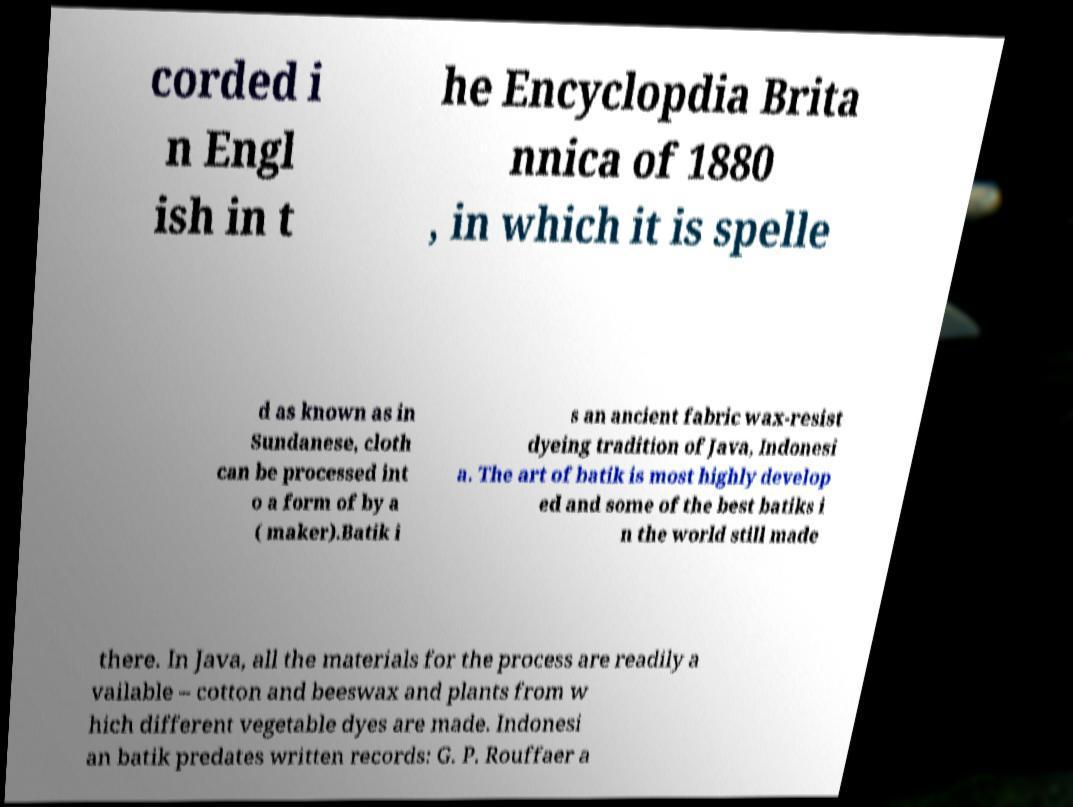Can you read and provide the text displayed in the image?This photo seems to have some interesting text. Can you extract and type it out for me? corded i n Engl ish in t he Encyclopdia Brita nnica of 1880 , in which it is spelle d as known as in Sundanese, cloth can be processed int o a form of by a ( maker).Batik i s an ancient fabric wax-resist dyeing tradition of Java, Indonesi a. The art of batik is most highly develop ed and some of the best batiks i n the world still made there. In Java, all the materials for the process are readily a vailable – cotton and beeswax and plants from w hich different vegetable dyes are made. Indonesi an batik predates written records: G. P. Rouffaer a 